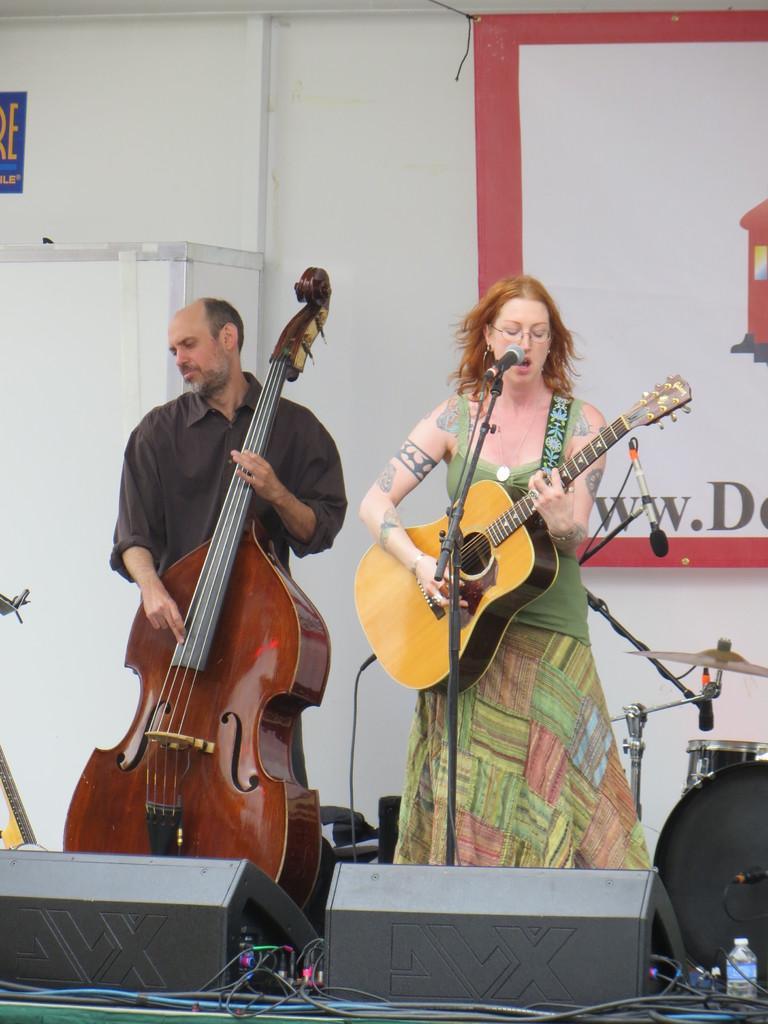Please provide a concise description of this image. this picture shows a man standing and playing a violin and a woman singing with the help of a microphone and playing a guitar. 